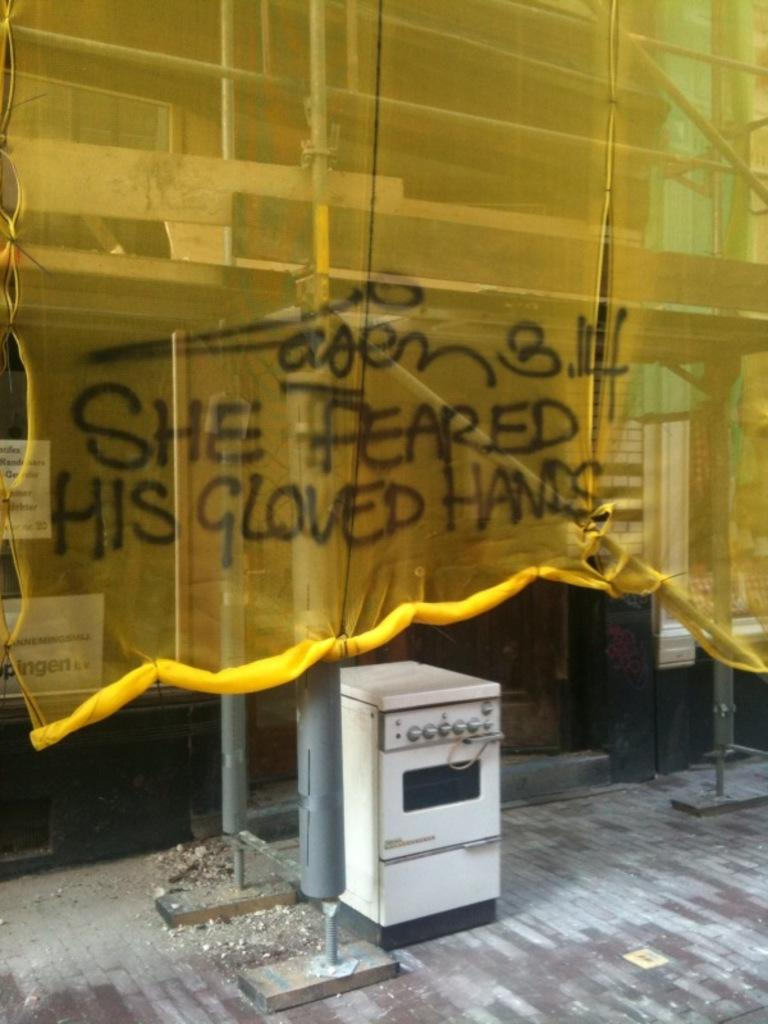<image>
Create a compact narrative representing the image presented. a yellow curtain has been spray pained with words about someone fearing his gloved hand 